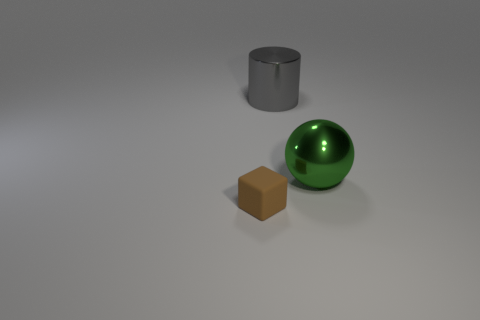Is there anything else that is the same size as the brown thing?
Give a very brief answer. No. How many big red cylinders are there?
Keep it short and to the point. 0. How many tiny things are either brown shiny blocks or brown rubber cubes?
Your answer should be compact. 1. The ball that is right of the shiny object that is behind the object right of the large gray thing is what color?
Provide a short and direct response. Green. What number of other objects are there of the same color as the big metal cylinder?
Make the answer very short. 0. What number of rubber objects are cylinders or cyan cylinders?
Your answer should be compact. 0. Is there anything else that is made of the same material as the brown thing?
Provide a succinct answer. No. Is the number of small cubes in front of the big green metal object greater than the number of green matte spheres?
Give a very brief answer. Yes. Are the big thing to the right of the big gray object and the brown thing made of the same material?
Your response must be concise. No. What size is the object in front of the metallic object that is to the right of the metallic thing to the left of the green sphere?
Your response must be concise. Small. 